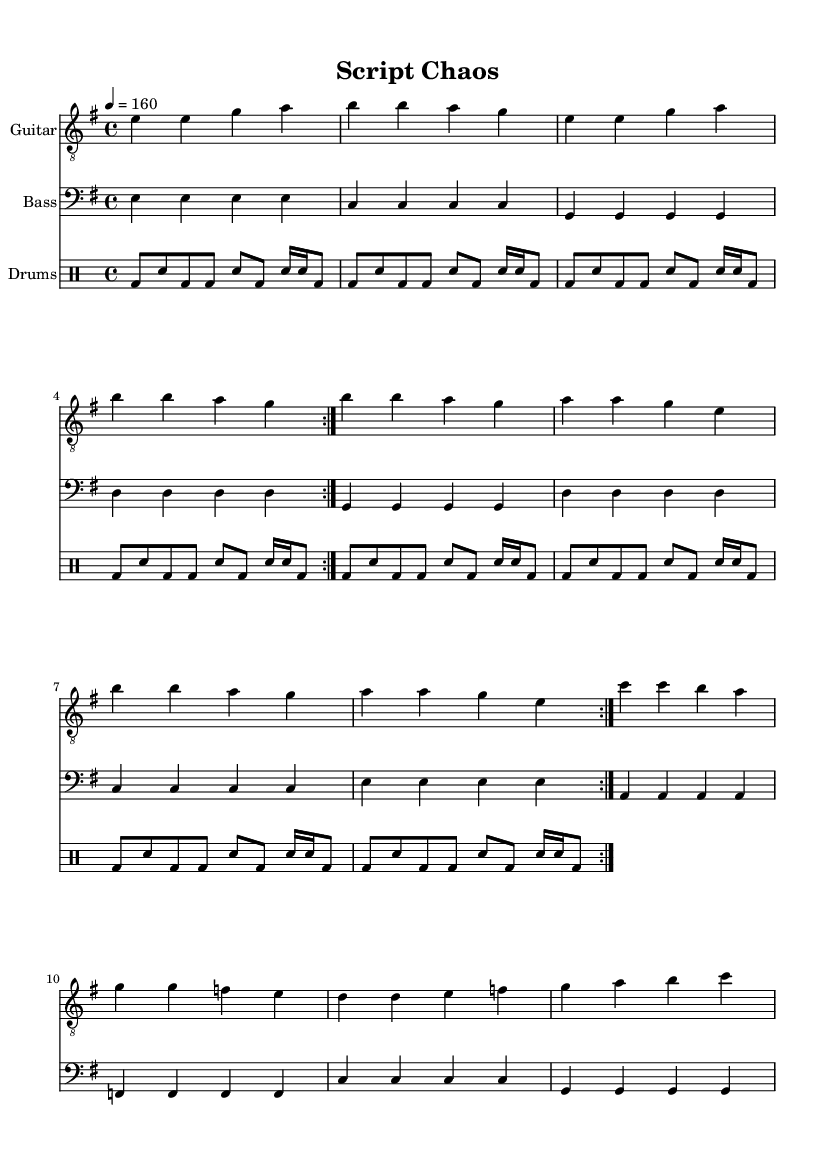What is the key signature of this music? The key signature is E minor, which has one sharp (F#) indicated by the key signature at the beginning of the staff.
Answer: E minor What is the time signature of this music? The time signature is 4/4, which means there are four beats in each measure and the quarter note receives one beat. This can be observed at the beginning of the score.
Answer: 4/4 What is the tempo marking for this piece? The tempo marking is 160 beats per minute, as indicated by '4 = 160' in the header, dictating the speed at which the music should be played.
Answer: 160 How many measures are repeated in the piece? There are two measures repeated in sections, indicated by the “\repeat volta 2” directive before the music sections for guitar and bass. Each of these sections is played twice.
Answer: 2 What is the dynamic level for the drum part? The drum part does not have specific dynamic markings. Therefore, it is understood to be played at a standard volume unless otherwise notated.
Answer: Standard Which instrument plays the melodic line primarily? The guitar plays the melodic line primarily, as it is the first staff and has the highest pitch range in the score compared to the bass and drums.
Answer: Guitar 